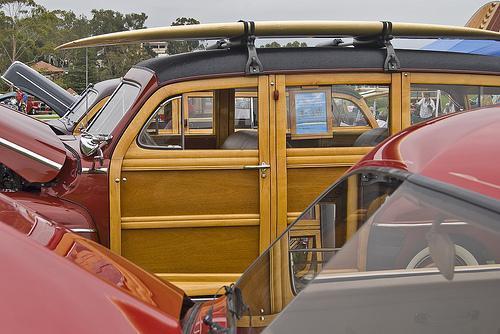How many surfboards?
Give a very brief answer. 1. 